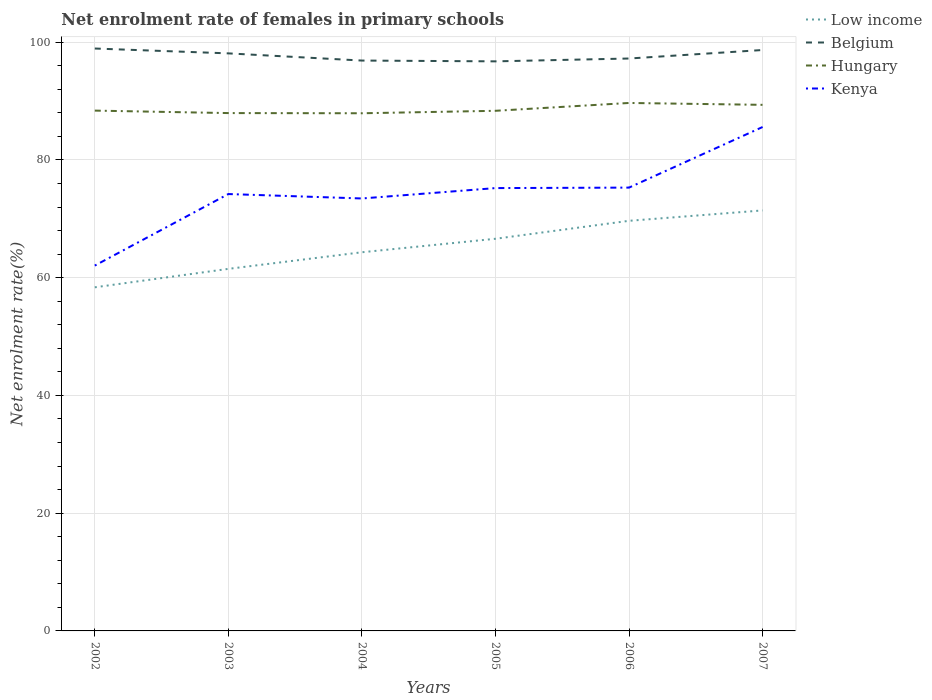How many different coloured lines are there?
Your answer should be very brief. 4. Across all years, what is the maximum net enrolment rate of females in primary schools in Belgium?
Provide a succinct answer. 96.75. In which year was the net enrolment rate of females in primary schools in Low income maximum?
Ensure brevity in your answer.  2002. What is the total net enrolment rate of females in primary schools in Belgium in the graph?
Offer a very short reply. -1.93. What is the difference between the highest and the second highest net enrolment rate of females in primary schools in Hungary?
Your response must be concise. 1.75. Are the values on the major ticks of Y-axis written in scientific E-notation?
Ensure brevity in your answer.  No. Does the graph contain any zero values?
Provide a short and direct response. No. How are the legend labels stacked?
Provide a short and direct response. Vertical. What is the title of the graph?
Your answer should be very brief. Net enrolment rate of females in primary schools. Does "Congo (Republic)" appear as one of the legend labels in the graph?
Offer a very short reply. No. What is the label or title of the X-axis?
Provide a short and direct response. Years. What is the label or title of the Y-axis?
Ensure brevity in your answer.  Net enrolment rate(%). What is the Net enrolment rate(%) in Low income in 2002?
Your answer should be compact. 58.37. What is the Net enrolment rate(%) in Belgium in 2002?
Your answer should be very brief. 98.93. What is the Net enrolment rate(%) of Hungary in 2002?
Your answer should be very brief. 88.38. What is the Net enrolment rate(%) in Kenya in 2002?
Your answer should be compact. 62.05. What is the Net enrolment rate(%) of Low income in 2003?
Your answer should be compact. 61.5. What is the Net enrolment rate(%) in Belgium in 2003?
Offer a terse response. 98.1. What is the Net enrolment rate(%) of Hungary in 2003?
Your answer should be compact. 87.96. What is the Net enrolment rate(%) in Kenya in 2003?
Give a very brief answer. 74.21. What is the Net enrolment rate(%) in Low income in 2004?
Your response must be concise. 64.32. What is the Net enrolment rate(%) in Belgium in 2004?
Ensure brevity in your answer.  96.88. What is the Net enrolment rate(%) in Hungary in 2004?
Make the answer very short. 87.93. What is the Net enrolment rate(%) in Kenya in 2004?
Provide a short and direct response. 73.46. What is the Net enrolment rate(%) of Low income in 2005?
Provide a short and direct response. 66.61. What is the Net enrolment rate(%) of Belgium in 2005?
Ensure brevity in your answer.  96.75. What is the Net enrolment rate(%) of Hungary in 2005?
Keep it short and to the point. 88.35. What is the Net enrolment rate(%) in Kenya in 2005?
Your response must be concise. 75.22. What is the Net enrolment rate(%) in Low income in 2006?
Keep it short and to the point. 69.66. What is the Net enrolment rate(%) of Belgium in 2006?
Your response must be concise. 97.23. What is the Net enrolment rate(%) of Hungary in 2006?
Your answer should be compact. 89.68. What is the Net enrolment rate(%) of Kenya in 2006?
Keep it short and to the point. 75.3. What is the Net enrolment rate(%) of Low income in 2007?
Provide a succinct answer. 71.43. What is the Net enrolment rate(%) in Belgium in 2007?
Offer a very short reply. 98.67. What is the Net enrolment rate(%) of Hungary in 2007?
Make the answer very short. 89.36. What is the Net enrolment rate(%) of Kenya in 2007?
Provide a succinct answer. 85.59. Across all years, what is the maximum Net enrolment rate(%) in Low income?
Make the answer very short. 71.43. Across all years, what is the maximum Net enrolment rate(%) in Belgium?
Give a very brief answer. 98.93. Across all years, what is the maximum Net enrolment rate(%) of Hungary?
Ensure brevity in your answer.  89.68. Across all years, what is the maximum Net enrolment rate(%) in Kenya?
Provide a short and direct response. 85.59. Across all years, what is the minimum Net enrolment rate(%) of Low income?
Give a very brief answer. 58.37. Across all years, what is the minimum Net enrolment rate(%) of Belgium?
Ensure brevity in your answer.  96.75. Across all years, what is the minimum Net enrolment rate(%) in Hungary?
Your response must be concise. 87.93. Across all years, what is the minimum Net enrolment rate(%) of Kenya?
Offer a terse response. 62.05. What is the total Net enrolment rate(%) of Low income in the graph?
Make the answer very short. 391.88. What is the total Net enrolment rate(%) of Belgium in the graph?
Offer a terse response. 586.55. What is the total Net enrolment rate(%) of Hungary in the graph?
Keep it short and to the point. 531.65. What is the total Net enrolment rate(%) in Kenya in the graph?
Make the answer very short. 445.83. What is the difference between the Net enrolment rate(%) of Low income in 2002 and that in 2003?
Your answer should be compact. -3.13. What is the difference between the Net enrolment rate(%) in Belgium in 2002 and that in 2003?
Ensure brevity in your answer.  0.83. What is the difference between the Net enrolment rate(%) in Hungary in 2002 and that in 2003?
Give a very brief answer. 0.42. What is the difference between the Net enrolment rate(%) of Kenya in 2002 and that in 2003?
Give a very brief answer. -12.15. What is the difference between the Net enrolment rate(%) in Low income in 2002 and that in 2004?
Give a very brief answer. -5.95. What is the difference between the Net enrolment rate(%) in Belgium in 2002 and that in 2004?
Your answer should be very brief. 2.05. What is the difference between the Net enrolment rate(%) of Hungary in 2002 and that in 2004?
Keep it short and to the point. 0.45. What is the difference between the Net enrolment rate(%) in Kenya in 2002 and that in 2004?
Your answer should be compact. -11.4. What is the difference between the Net enrolment rate(%) of Low income in 2002 and that in 2005?
Make the answer very short. -8.24. What is the difference between the Net enrolment rate(%) in Belgium in 2002 and that in 2005?
Keep it short and to the point. 2.18. What is the difference between the Net enrolment rate(%) in Hungary in 2002 and that in 2005?
Provide a succinct answer. 0.03. What is the difference between the Net enrolment rate(%) of Kenya in 2002 and that in 2005?
Provide a succinct answer. -13.16. What is the difference between the Net enrolment rate(%) in Low income in 2002 and that in 2006?
Ensure brevity in your answer.  -11.3. What is the difference between the Net enrolment rate(%) in Belgium in 2002 and that in 2006?
Make the answer very short. 1.7. What is the difference between the Net enrolment rate(%) in Hungary in 2002 and that in 2006?
Provide a succinct answer. -1.3. What is the difference between the Net enrolment rate(%) of Kenya in 2002 and that in 2006?
Provide a succinct answer. -13.25. What is the difference between the Net enrolment rate(%) of Low income in 2002 and that in 2007?
Your answer should be compact. -13.06. What is the difference between the Net enrolment rate(%) in Belgium in 2002 and that in 2007?
Ensure brevity in your answer.  0.25. What is the difference between the Net enrolment rate(%) of Hungary in 2002 and that in 2007?
Give a very brief answer. -0.98. What is the difference between the Net enrolment rate(%) in Kenya in 2002 and that in 2007?
Your answer should be compact. -23.54. What is the difference between the Net enrolment rate(%) of Low income in 2003 and that in 2004?
Offer a very short reply. -2.82. What is the difference between the Net enrolment rate(%) of Belgium in 2003 and that in 2004?
Provide a short and direct response. 1.22. What is the difference between the Net enrolment rate(%) in Hungary in 2003 and that in 2004?
Your answer should be very brief. 0.03. What is the difference between the Net enrolment rate(%) in Kenya in 2003 and that in 2004?
Offer a very short reply. 0.75. What is the difference between the Net enrolment rate(%) of Low income in 2003 and that in 2005?
Offer a very short reply. -5.11. What is the difference between the Net enrolment rate(%) in Belgium in 2003 and that in 2005?
Your answer should be very brief. 1.35. What is the difference between the Net enrolment rate(%) in Hungary in 2003 and that in 2005?
Your response must be concise. -0.39. What is the difference between the Net enrolment rate(%) in Kenya in 2003 and that in 2005?
Provide a succinct answer. -1.01. What is the difference between the Net enrolment rate(%) in Low income in 2003 and that in 2006?
Make the answer very short. -8.16. What is the difference between the Net enrolment rate(%) of Belgium in 2003 and that in 2006?
Keep it short and to the point. 0.87. What is the difference between the Net enrolment rate(%) in Hungary in 2003 and that in 2006?
Provide a short and direct response. -1.72. What is the difference between the Net enrolment rate(%) of Kenya in 2003 and that in 2006?
Provide a succinct answer. -1.09. What is the difference between the Net enrolment rate(%) of Low income in 2003 and that in 2007?
Ensure brevity in your answer.  -9.93. What is the difference between the Net enrolment rate(%) in Belgium in 2003 and that in 2007?
Keep it short and to the point. -0.57. What is the difference between the Net enrolment rate(%) of Hungary in 2003 and that in 2007?
Your response must be concise. -1.4. What is the difference between the Net enrolment rate(%) of Kenya in 2003 and that in 2007?
Your response must be concise. -11.39. What is the difference between the Net enrolment rate(%) of Low income in 2004 and that in 2005?
Keep it short and to the point. -2.29. What is the difference between the Net enrolment rate(%) of Belgium in 2004 and that in 2005?
Provide a short and direct response. 0.13. What is the difference between the Net enrolment rate(%) of Hungary in 2004 and that in 2005?
Your answer should be very brief. -0.42. What is the difference between the Net enrolment rate(%) of Kenya in 2004 and that in 2005?
Your answer should be very brief. -1.76. What is the difference between the Net enrolment rate(%) in Low income in 2004 and that in 2006?
Your answer should be very brief. -5.34. What is the difference between the Net enrolment rate(%) of Belgium in 2004 and that in 2006?
Your answer should be very brief. -0.35. What is the difference between the Net enrolment rate(%) of Hungary in 2004 and that in 2006?
Make the answer very short. -1.75. What is the difference between the Net enrolment rate(%) in Kenya in 2004 and that in 2006?
Keep it short and to the point. -1.85. What is the difference between the Net enrolment rate(%) in Low income in 2004 and that in 2007?
Give a very brief answer. -7.11. What is the difference between the Net enrolment rate(%) in Belgium in 2004 and that in 2007?
Provide a short and direct response. -1.79. What is the difference between the Net enrolment rate(%) of Hungary in 2004 and that in 2007?
Your answer should be very brief. -1.43. What is the difference between the Net enrolment rate(%) in Kenya in 2004 and that in 2007?
Give a very brief answer. -12.14. What is the difference between the Net enrolment rate(%) of Low income in 2005 and that in 2006?
Offer a very short reply. -3.05. What is the difference between the Net enrolment rate(%) of Belgium in 2005 and that in 2006?
Give a very brief answer. -0.48. What is the difference between the Net enrolment rate(%) of Hungary in 2005 and that in 2006?
Your response must be concise. -1.33. What is the difference between the Net enrolment rate(%) in Kenya in 2005 and that in 2006?
Provide a succinct answer. -0.08. What is the difference between the Net enrolment rate(%) of Low income in 2005 and that in 2007?
Your answer should be very brief. -4.82. What is the difference between the Net enrolment rate(%) in Belgium in 2005 and that in 2007?
Keep it short and to the point. -1.93. What is the difference between the Net enrolment rate(%) of Hungary in 2005 and that in 2007?
Make the answer very short. -1.01. What is the difference between the Net enrolment rate(%) in Kenya in 2005 and that in 2007?
Keep it short and to the point. -10.38. What is the difference between the Net enrolment rate(%) of Low income in 2006 and that in 2007?
Ensure brevity in your answer.  -1.77. What is the difference between the Net enrolment rate(%) in Belgium in 2006 and that in 2007?
Your answer should be very brief. -1.44. What is the difference between the Net enrolment rate(%) of Hungary in 2006 and that in 2007?
Ensure brevity in your answer.  0.32. What is the difference between the Net enrolment rate(%) in Kenya in 2006 and that in 2007?
Your response must be concise. -10.29. What is the difference between the Net enrolment rate(%) in Low income in 2002 and the Net enrolment rate(%) in Belgium in 2003?
Your answer should be compact. -39.74. What is the difference between the Net enrolment rate(%) of Low income in 2002 and the Net enrolment rate(%) of Hungary in 2003?
Your answer should be very brief. -29.59. What is the difference between the Net enrolment rate(%) in Low income in 2002 and the Net enrolment rate(%) in Kenya in 2003?
Your response must be concise. -15.84. What is the difference between the Net enrolment rate(%) in Belgium in 2002 and the Net enrolment rate(%) in Hungary in 2003?
Offer a terse response. 10.97. What is the difference between the Net enrolment rate(%) in Belgium in 2002 and the Net enrolment rate(%) in Kenya in 2003?
Provide a succinct answer. 24.72. What is the difference between the Net enrolment rate(%) of Hungary in 2002 and the Net enrolment rate(%) of Kenya in 2003?
Make the answer very short. 14.17. What is the difference between the Net enrolment rate(%) of Low income in 2002 and the Net enrolment rate(%) of Belgium in 2004?
Keep it short and to the point. -38.51. What is the difference between the Net enrolment rate(%) of Low income in 2002 and the Net enrolment rate(%) of Hungary in 2004?
Ensure brevity in your answer.  -29.56. What is the difference between the Net enrolment rate(%) in Low income in 2002 and the Net enrolment rate(%) in Kenya in 2004?
Offer a terse response. -15.09. What is the difference between the Net enrolment rate(%) of Belgium in 2002 and the Net enrolment rate(%) of Hungary in 2004?
Offer a terse response. 11. What is the difference between the Net enrolment rate(%) in Belgium in 2002 and the Net enrolment rate(%) in Kenya in 2004?
Ensure brevity in your answer.  25.47. What is the difference between the Net enrolment rate(%) of Hungary in 2002 and the Net enrolment rate(%) of Kenya in 2004?
Offer a terse response. 14.92. What is the difference between the Net enrolment rate(%) in Low income in 2002 and the Net enrolment rate(%) in Belgium in 2005?
Offer a terse response. -38.38. What is the difference between the Net enrolment rate(%) in Low income in 2002 and the Net enrolment rate(%) in Hungary in 2005?
Offer a very short reply. -29.98. What is the difference between the Net enrolment rate(%) in Low income in 2002 and the Net enrolment rate(%) in Kenya in 2005?
Provide a succinct answer. -16.85. What is the difference between the Net enrolment rate(%) of Belgium in 2002 and the Net enrolment rate(%) of Hungary in 2005?
Make the answer very short. 10.58. What is the difference between the Net enrolment rate(%) in Belgium in 2002 and the Net enrolment rate(%) in Kenya in 2005?
Your answer should be compact. 23.71. What is the difference between the Net enrolment rate(%) in Hungary in 2002 and the Net enrolment rate(%) in Kenya in 2005?
Make the answer very short. 13.16. What is the difference between the Net enrolment rate(%) in Low income in 2002 and the Net enrolment rate(%) in Belgium in 2006?
Your answer should be very brief. -38.86. What is the difference between the Net enrolment rate(%) of Low income in 2002 and the Net enrolment rate(%) of Hungary in 2006?
Your response must be concise. -31.31. What is the difference between the Net enrolment rate(%) of Low income in 2002 and the Net enrolment rate(%) of Kenya in 2006?
Ensure brevity in your answer.  -16.94. What is the difference between the Net enrolment rate(%) in Belgium in 2002 and the Net enrolment rate(%) in Hungary in 2006?
Provide a short and direct response. 9.25. What is the difference between the Net enrolment rate(%) of Belgium in 2002 and the Net enrolment rate(%) of Kenya in 2006?
Offer a terse response. 23.62. What is the difference between the Net enrolment rate(%) in Hungary in 2002 and the Net enrolment rate(%) in Kenya in 2006?
Your answer should be compact. 13.08. What is the difference between the Net enrolment rate(%) in Low income in 2002 and the Net enrolment rate(%) in Belgium in 2007?
Offer a terse response. -40.31. What is the difference between the Net enrolment rate(%) of Low income in 2002 and the Net enrolment rate(%) of Hungary in 2007?
Provide a short and direct response. -30.99. What is the difference between the Net enrolment rate(%) of Low income in 2002 and the Net enrolment rate(%) of Kenya in 2007?
Provide a short and direct response. -27.23. What is the difference between the Net enrolment rate(%) in Belgium in 2002 and the Net enrolment rate(%) in Hungary in 2007?
Provide a short and direct response. 9.57. What is the difference between the Net enrolment rate(%) in Belgium in 2002 and the Net enrolment rate(%) in Kenya in 2007?
Provide a succinct answer. 13.33. What is the difference between the Net enrolment rate(%) of Hungary in 2002 and the Net enrolment rate(%) of Kenya in 2007?
Provide a short and direct response. 2.78. What is the difference between the Net enrolment rate(%) of Low income in 2003 and the Net enrolment rate(%) of Belgium in 2004?
Give a very brief answer. -35.38. What is the difference between the Net enrolment rate(%) of Low income in 2003 and the Net enrolment rate(%) of Hungary in 2004?
Ensure brevity in your answer.  -26.43. What is the difference between the Net enrolment rate(%) of Low income in 2003 and the Net enrolment rate(%) of Kenya in 2004?
Your answer should be very brief. -11.96. What is the difference between the Net enrolment rate(%) in Belgium in 2003 and the Net enrolment rate(%) in Hungary in 2004?
Provide a succinct answer. 10.17. What is the difference between the Net enrolment rate(%) in Belgium in 2003 and the Net enrolment rate(%) in Kenya in 2004?
Keep it short and to the point. 24.65. What is the difference between the Net enrolment rate(%) in Hungary in 2003 and the Net enrolment rate(%) in Kenya in 2004?
Your answer should be compact. 14.5. What is the difference between the Net enrolment rate(%) of Low income in 2003 and the Net enrolment rate(%) of Belgium in 2005?
Make the answer very short. -35.25. What is the difference between the Net enrolment rate(%) in Low income in 2003 and the Net enrolment rate(%) in Hungary in 2005?
Provide a short and direct response. -26.85. What is the difference between the Net enrolment rate(%) of Low income in 2003 and the Net enrolment rate(%) of Kenya in 2005?
Ensure brevity in your answer.  -13.72. What is the difference between the Net enrolment rate(%) of Belgium in 2003 and the Net enrolment rate(%) of Hungary in 2005?
Offer a very short reply. 9.75. What is the difference between the Net enrolment rate(%) in Belgium in 2003 and the Net enrolment rate(%) in Kenya in 2005?
Make the answer very short. 22.88. What is the difference between the Net enrolment rate(%) in Hungary in 2003 and the Net enrolment rate(%) in Kenya in 2005?
Your answer should be very brief. 12.74. What is the difference between the Net enrolment rate(%) in Low income in 2003 and the Net enrolment rate(%) in Belgium in 2006?
Offer a terse response. -35.73. What is the difference between the Net enrolment rate(%) of Low income in 2003 and the Net enrolment rate(%) of Hungary in 2006?
Your answer should be compact. -28.18. What is the difference between the Net enrolment rate(%) in Low income in 2003 and the Net enrolment rate(%) in Kenya in 2006?
Provide a short and direct response. -13.8. What is the difference between the Net enrolment rate(%) in Belgium in 2003 and the Net enrolment rate(%) in Hungary in 2006?
Offer a terse response. 8.42. What is the difference between the Net enrolment rate(%) of Belgium in 2003 and the Net enrolment rate(%) of Kenya in 2006?
Provide a short and direct response. 22.8. What is the difference between the Net enrolment rate(%) in Hungary in 2003 and the Net enrolment rate(%) in Kenya in 2006?
Your answer should be very brief. 12.66. What is the difference between the Net enrolment rate(%) of Low income in 2003 and the Net enrolment rate(%) of Belgium in 2007?
Offer a terse response. -37.17. What is the difference between the Net enrolment rate(%) of Low income in 2003 and the Net enrolment rate(%) of Hungary in 2007?
Provide a succinct answer. -27.86. What is the difference between the Net enrolment rate(%) in Low income in 2003 and the Net enrolment rate(%) in Kenya in 2007?
Your answer should be very brief. -24.1. What is the difference between the Net enrolment rate(%) of Belgium in 2003 and the Net enrolment rate(%) of Hungary in 2007?
Offer a terse response. 8.74. What is the difference between the Net enrolment rate(%) of Belgium in 2003 and the Net enrolment rate(%) of Kenya in 2007?
Offer a terse response. 12.51. What is the difference between the Net enrolment rate(%) in Hungary in 2003 and the Net enrolment rate(%) in Kenya in 2007?
Offer a terse response. 2.36. What is the difference between the Net enrolment rate(%) in Low income in 2004 and the Net enrolment rate(%) in Belgium in 2005?
Offer a very short reply. -32.43. What is the difference between the Net enrolment rate(%) of Low income in 2004 and the Net enrolment rate(%) of Hungary in 2005?
Your response must be concise. -24.03. What is the difference between the Net enrolment rate(%) of Low income in 2004 and the Net enrolment rate(%) of Kenya in 2005?
Provide a succinct answer. -10.9. What is the difference between the Net enrolment rate(%) in Belgium in 2004 and the Net enrolment rate(%) in Hungary in 2005?
Provide a short and direct response. 8.53. What is the difference between the Net enrolment rate(%) in Belgium in 2004 and the Net enrolment rate(%) in Kenya in 2005?
Offer a very short reply. 21.66. What is the difference between the Net enrolment rate(%) of Hungary in 2004 and the Net enrolment rate(%) of Kenya in 2005?
Your answer should be compact. 12.71. What is the difference between the Net enrolment rate(%) of Low income in 2004 and the Net enrolment rate(%) of Belgium in 2006?
Ensure brevity in your answer.  -32.91. What is the difference between the Net enrolment rate(%) in Low income in 2004 and the Net enrolment rate(%) in Hungary in 2006?
Provide a succinct answer. -25.36. What is the difference between the Net enrolment rate(%) of Low income in 2004 and the Net enrolment rate(%) of Kenya in 2006?
Keep it short and to the point. -10.98. What is the difference between the Net enrolment rate(%) of Belgium in 2004 and the Net enrolment rate(%) of Hungary in 2006?
Offer a terse response. 7.2. What is the difference between the Net enrolment rate(%) of Belgium in 2004 and the Net enrolment rate(%) of Kenya in 2006?
Your answer should be compact. 21.58. What is the difference between the Net enrolment rate(%) in Hungary in 2004 and the Net enrolment rate(%) in Kenya in 2006?
Your answer should be very brief. 12.63. What is the difference between the Net enrolment rate(%) of Low income in 2004 and the Net enrolment rate(%) of Belgium in 2007?
Your answer should be compact. -34.35. What is the difference between the Net enrolment rate(%) of Low income in 2004 and the Net enrolment rate(%) of Hungary in 2007?
Your answer should be very brief. -25.04. What is the difference between the Net enrolment rate(%) in Low income in 2004 and the Net enrolment rate(%) in Kenya in 2007?
Your answer should be compact. -21.28. What is the difference between the Net enrolment rate(%) of Belgium in 2004 and the Net enrolment rate(%) of Hungary in 2007?
Provide a succinct answer. 7.52. What is the difference between the Net enrolment rate(%) of Belgium in 2004 and the Net enrolment rate(%) of Kenya in 2007?
Ensure brevity in your answer.  11.29. What is the difference between the Net enrolment rate(%) of Hungary in 2004 and the Net enrolment rate(%) of Kenya in 2007?
Your answer should be compact. 2.33. What is the difference between the Net enrolment rate(%) of Low income in 2005 and the Net enrolment rate(%) of Belgium in 2006?
Ensure brevity in your answer.  -30.62. What is the difference between the Net enrolment rate(%) in Low income in 2005 and the Net enrolment rate(%) in Hungary in 2006?
Provide a short and direct response. -23.07. What is the difference between the Net enrolment rate(%) in Low income in 2005 and the Net enrolment rate(%) in Kenya in 2006?
Give a very brief answer. -8.69. What is the difference between the Net enrolment rate(%) of Belgium in 2005 and the Net enrolment rate(%) of Hungary in 2006?
Your response must be concise. 7.07. What is the difference between the Net enrolment rate(%) in Belgium in 2005 and the Net enrolment rate(%) in Kenya in 2006?
Offer a terse response. 21.44. What is the difference between the Net enrolment rate(%) in Hungary in 2005 and the Net enrolment rate(%) in Kenya in 2006?
Your answer should be very brief. 13.05. What is the difference between the Net enrolment rate(%) in Low income in 2005 and the Net enrolment rate(%) in Belgium in 2007?
Your answer should be very brief. -32.06. What is the difference between the Net enrolment rate(%) of Low income in 2005 and the Net enrolment rate(%) of Hungary in 2007?
Make the answer very short. -22.75. What is the difference between the Net enrolment rate(%) of Low income in 2005 and the Net enrolment rate(%) of Kenya in 2007?
Ensure brevity in your answer.  -18.98. What is the difference between the Net enrolment rate(%) of Belgium in 2005 and the Net enrolment rate(%) of Hungary in 2007?
Your answer should be very brief. 7.39. What is the difference between the Net enrolment rate(%) in Belgium in 2005 and the Net enrolment rate(%) in Kenya in 2007?
Offer a terse response. 11.15. What is the difference between the Net enrolment rate(%) in Hungary in 2005 and the Net enrolment rate(%) in Kenya in 2007?
Your response must be concise. 2.75. What is the difference between the Net enrolment rate(%) in Low income in 2006 and the Net enrolment rate(%) in Belgium in 2007?
Your answer should be compact. -29.01. What is the difference between the Net enrolment rate(%) of Low income in 2006 and the Net enrolment rate(%) of Hungary in 2007?
Give a very brief answer. -19.7. What is the difference between the Net enrolment rate(%) of Low income in 2006 and the Net enrolment rate(%) of Kenya in 2007?
Your answer should be compact. -15.93. What is the difference between the Net enrolment rate(%) of Belgium in 2006 and the Net enrolment rate(%) of Hungary in 2007?
Offer a terse response. 7.87. What is the difference between the Net enrolment rate(%) of Belgium in 2006 and the Net enrolment rate(%) of Kenya in 2007?
Provide a short and direct response. 11.63. What is the difference between the Net enrolment rate(%) in Hungary in 2006 and the Net enrolment rate(%) in Kenya in 2007?
Your answer should be very brief. 4.08. What is the average Net enrolment rate(%) in Low income per year?
Keep it short and to the point. 65.31. What is the average Net enrolment rate(%) of Belgium per year?
Your answer should be very brief. 97.76. What is the average Net enrolment rate(%) in Hungary per year?
Make the answer very short. 88.61. What is the average Net enrolment rate(%) of Kenya per year?
Offer a very short reply. 74.31. In the year 2002, what is the difference between the Net enrolment rate(%) of Low income and Net enrolment rate(%) of Belgium?
Make the answer very short. -40.56. In the year 2002, what is the difference between the Net enrolment rate(%) in Low income and Net enrolment rate(%) in Hungary?
Your answer should be very brief. -30.01. In the year 2002, what is the difference between the Net enrolment rate(%) in Low income and Net enrolment rate(%) in Kenya?
Provide a short and direct response. -3.69. In the year 2002, what is the difference between the Net enrolment rate(%) of Belgium and Net enrolment rate(%) of Hungary?
Make the answer very short. 10.55. In the year 2002, what is the difference between the Net enrolment rate(%) in Belgium and Net enrolment rate(%) in Kenya?
Make the answer very short. 36.87. In the year 2002, what is the difference between the Net enrolment rate(%) in Hungary and Net enrolment rate(%) in Kenya?
Your answer should be very brief. 26.32. In the year 2003, what is the difference between the Net enrolment rate(%) in Low income and Net enrolment rate(%) in Belgium?
Ensure brevity in your answer.  -36.6. In the year 2003, what is the difference between the Net enrolment rate(%) in Low income and Net enrolment rate(%) in Hungary?
Provide a succinct answer. -26.46. In the year 2003, what is the difference between the Net enrolment rate(%) in Low income and Net enrolment rate(%) in Kenya?
Provide a short and direct response. -12.71. In the year 2003, what is the difference between the Net enrolment rate(%) in Belgium and Net enrolment rate(%) in Hungary?
Provide a short and direct response. 10.14. In the year 2003, what is the difference between the Net enrolment rate(%) of Belgium and Net enrolment rate(%) of Kenya?
Ensure brevity in your answer.  23.89. In the year 2003, what is the difference between the Net enrolment rate(%) of Hungary and Net enrolment rate(%) of Kenya?
Give a very brief answer. 13.75. In the year 2004, what is the difference between the Net enrolment rate(%) of Low income and Net enrolment rate(%) of Belgium?
Offer a terse response. -32.56. In the year 2004, what is the difference between the Net enrolment rate(%) of Low income and Net enrolment rate(%) of Hungary?
Provide a succinct answer. -23.61. In the year 2004, what is the difference between the Net enrolment rate(%) of Low income and Net enrolment rate(%) of Kenya?
Provide a succinct answer. -9.14. In the year 2004, what is the difference between the Net enrolment rate(%) of Belgium and Net enrolment rate(%) of Hungary?
Give a very brief answer. 8.95. In the year 2004, what is the difference between the Net enrolment rate(%) of Belgium and Net enrolment rate(%) of Kenya?
Offer a very short reply. 23.42. In the year 2004, what is the difference between the Net enrolment rate(%) of Hungary and Net enrolment rate(%) of Kenya?
Your response must be concise. 14.47. In the year 2005, what is the difference between the Net enrolment rate(%) of Low income and Net enrolment rate(%) of Belgium?
Provide a short and direct response. -30.14. In the year 2005, what is the difference between the Net enrolment rate(%) of Low income and Net enrolment rate(%) of Hungary?
Your response must be concise. -21.74. In the year 2005, what is the difference between the Net enrolment rate(%) of Low income and Net enrolment rate(%) of Kenya?
Provide a short and direct response. -8.61. In the year 2005, what is the difference between the Net enrolment rate(%) in Belgium and Net enrolment rate(%) in Hungary?
Offer a terse response. 8.4. In the year 2005, what is the difference between the Net enrolment rate(%) of Belgium and Net enrolment rate(%) of Kenya?
Make the answer very short. 21.53. In the year 2005, what is the difference between the Net enrolment rate(%) of Hungary and Net enrolment rate(%) of Kenya?
Make the answer very short. 13.13. In the year 2006, what is the difference between the Net enrolment rate(%) in Low income and Net enrolment rate(%) in Belgium?
Ensure brevity in your answer.  -27.57. In the year 2006, what is the difference between the Net enrolment rate(%) of Low income and Net enrolment rate(%) of Hungary?
Offer a terse response. -20.02. In the year 2006, what is the difference between the Net enrolment rate(%) in Low income and Net enrolment rate(%) in Kenya?
Your answer should be very brief. -5.64. In the year 2006, what is the difference between the Net enrolment rate(%) of Belgium and Net enrolment rate(%) of Hungary?
Offer a very short reply. 7.55. In the year 2006, what is the difference between the Net enrolment rate(%) of Belgium and Net enrolment rate(%) of Kenya?
Provide a short and direct response. 21.93. In the year 2006, what is the difference between the Net enrolment rate(%) in Hungary and Net enrolment rate(%) in Kenya?
Your answer should be very brief. 14.38. In the year 2007, what is the difference between the Net enrolment rate(%) in Low income and Net enrolment rate(%) in Belgium?
Provide a succinct answer. -27.25. In the year 2007, what is the difference between the Net enrolment rate(%) in Low income and Net enrolment rate(%) in Hungary?
Provide a short and direct response. -17.93. In the year 2007, what is the difference between the Net enrolment rate(%) of Low income and Net enrolment rate(%) of Kenya?
Offer a terse response. -14.17. In the year 2007, what is the difference between the Net enrolment rate(%) in Belgium and Net enrolment rate(%) in Hungary?
Your response must be concise. 9.31. In the year 2007, what is the difference between the Net enrolment rate(%) of Belgium and Net enrolment rate(%) of Kenya?
Offer a very short reply. 13.08. In the year 2007, what is the difference between the Net enrolment rate(%) in Hungary and Net enrolment rate(%) in Kenya?
Keep it short and to the point. 3.76. What is the ratio of the Net enrolment rate(%) of Low income in 2002 to that in 2003?
Ensure brevity in your answer.  0.95. What is the ratio of the Net enrolment rate(%) in Belgium in 2002 to that in 2003?
Offer a very short reply. 1.01. What is the ratio of the Net enrolment rate(%) in Kenya in 2002 to that in 2003?
Make the answer very short. 0.84. What is the ratio of the Net enrolment rate(%) in Low income in 2002 to that in 2004?
Make the answer very short. 0.91. What is the ratio of the Net enrolment rate(%) of Belgium in 2002 to that in 2004?
Offer a terse response. 1.02. What is the ratio of the Net enrolment rate(%) of Kenya in 2002 to that in 2004?
Ensure brevity in your answer.  0.84. What is the ratio of the Net enrolment rate(%) of Low income in 2002 to that in 2005?
Your answer should be very brief. 0.88. What is the ratio of the Net enrolment rate(%) of Belgium in 2002 to that in 2005?
Your response must be concise. 1.02. What is the ratio of the Net enrolment rate(%) of Hungary in 2002 to that in 2005?
Provide a succinct answer. 1. What is the ratio of the Net enrolment rate(%) of Kenya in 2002 to that in 2005?
Your answer should be very brief. 0.82. What is the ratio of the Net enrolment rate(%) in Low income in 2002 to that in 2006?
Offer a terse response. 0.84. What is the ratio of the Net enrolment rate(%) of Belgium in 2002 to that in 2006?
Your answer should be very brief. 1.02. What is the ratio of the Net enrolment rate(%) of Hungary in 2002 to that in 2006?
Make the answer very short. 0.99. What is the ratio of the Net enrolment rate(%) of Kenya in 2002 to that in 2006?
Your answer should be compact. 0.82. What is the ratio of the Net enrolment rate(%) in Low income in 2002 to that in 2007?
Provide a short and direct response. 0.82. What is the ratio of the Net enrolment rate(%) in Hungary in 2002 to that in 2007?
Offer a terse response. 0.99. What is the ratio of the Net enrolment rate(%) in Kenya in 2002 to that in 2007?
Offer a terse response. 0.72. What is the ratio of the Net enrolment rate(%) in Low income in 2003 to that in 2004?
Ensure brevity in your answer.  0.96. What is the ratio of the Net enrolment rate(%) in Belgium in 2003 to that in 2004?
Provide a succinct answer. 1.01. What is the ratio of the Net enrolment rate(%) in Hungary in 2003 to that in 2004?
Offer a very short reply. 1. What is the ratio of the Net enrolment rate(%) of Kenya in 2003 to that in 2004?
Offer a terse response. 1.01. What is the ratio of the Net enrolment rate(%) in Low income in 2003 to that in 2005?
Your answer should be very brief. 0.92. What is the ratio of the Net enrolment rate(%) of Belgium in 2003 to that in 2005?
Offer a terse response. 1.01. What is the ratio of the Net enrolment rate(%) of Kenya in 2003 to that in 2005?
Keep it short and to the point. 0.99. What is the ratio of the Net enrolment rate(%) of Low income in 2003 to that in 2006?
Your response must be concise. 0.88. What is the ratio of the Net enrolment rate(%) of Belgium in 2003 to that in 2006?
Provide a short and direct response. 1.01. What is the ratio of the Net enrolment rate(%) in Hungary in 2003 to that in 2006?
Ensure brevity in your answer.  0.98. What is the ratio of the Net enrolment rate(%) in Kenya in 2003 to that in 2006?
Offer a very short reply. 0.99. What is the ratio of the Net enrolment rate(%) of Low income in 2003 to that in 2007?
Your answer should be compact. 0.86. What is the ratio of the Net enrolment rate(%) in Hungary in 2003 to that in 2007?
Keep it short and to the point. 0.98. What is the ratio of the Net enrolment rate(%) of Kenya in 2003 to that in 2007?
Your answer should be very brief. 0.87. What is the ratio of the Net enrolment rate(%) of Low income in 2004 to that in 2005?
Keep it short and to the point. 0.97. What is the ratio of the Net enrolment rate(%) of Hungary in 2004 to that in 2005?
Offer a very short reply. 1. What is the ratio of the Net enrolment rate(%) of Kenya in 2004 to that in 2005?
Give a very brief answer. 0.98. What is the ratio of the Net enrolment rate(%) in Low income in 2004 to that in 2006?
Provide a succinct answer. 0.92. What is the ratio of the Net enrolment rate(%) in Hungary in 2004 to that in 2006?
Offer a terse response. 0.98. What is the ratio of the Net enrolment rate(%) in Kenya in 2004 to that in 2006?
Ensure brevity in your answer.  0.98. What is the ratio of the Net enrolment rate(%) in Low income in 2004 to that in 2007?
Ensure brevity in your answer.  0.9. What is the ratio of the Net enrolment rate(%) in Belgium in 2004 to that in 2007?
Keep it short and to the point. 0.98. What is the ratio of the Net enrolment rate(%) in Kenya in 2004 to that in 2007?
Your answer should be very brief. 0.86. What is the ratio of the Net enrolment rate(%) in Low income in 2005 to that in 2006?
Ensure brevity in your answer.  0.96. What is the ratio of the Net enrolment rate(%) in Belgium in 2005 to that in 2006?
Your response must be concise. 0.99. What is the ratio of the Net enrolment rate(%) of Hungary in 2005 to that in 2006?
Your response must be concise. 0.99. What is the ratio of the Net enrolment rate(%) of Low income in 2005 to that in 2007?
Your answer should be compact. 0.93. What is the ratio of the Net enrolment rate(%) of Belgium in 2005 to that in 2007?
Ensure brevity in your answer.  0.98. What is the ratio of the Net enrolment rate(%) of Hungary in 2005 to that in 2007?
Offer a terse response. 0.99. What is the ratio of the Net enrolment rate(%) of Kenya in 2005 to that in 2007?
Your response must be concise. 0.88. What is the ratio of the Net enrolment rate(%) of Low income in 2006 to that in 2007?
Your answer should be compact. 0.98. What is the ratio of the Net enrolment rate(%) of Belgium in 2006 to that in 2007?
Offer a very short reply. 0.99. What is the ratio of the Net enrolment rate(%) in Kenya in 2006 to that in 2007?
Ensure brevity in your answer.  0.88. What is the difference between the highest and the second highest Net enrolment rate(%) in Low income?
Provide a succinct answer. 1.77. What is the difference between the highest and the second highest Net enrolment rate(%) in Belgium?
Your response must be concise. 0.25. What is the difference between the highest and the second highest Net enrolment rate(%) of Hungary?
Make the answer very short. 0.32. What is the difference between the highest and the second highest Net enrolment rate(%) in Kenya?
Your response must be concise. 10.29. What is the difference between the highest and the lowest Net enrolment rate(%) of Low income?
Give a very brief answer. 13.06. What is the difference between the highest and the lowest Net enrolment rate(%) of Belgium?
Your answer should be very brief. 2.18. What is the difference between the highest and the lowest Net enrolment rate(%) in Hungary?
Keep it short and to the point. 1.75. What is the difference between the highest and the lowest Net enrolment rate(%) in Kenya?
Your answer should be compact. 23.54. 